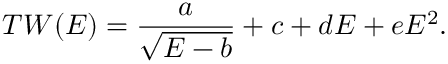Convert formula to latex. <formula><loc_0><loc_0><loc_500><loc_500>T W ( E ) = \frac { a } { \sqrt { E - b } } + c + d E + e E ^ { 2 } .</formula> 